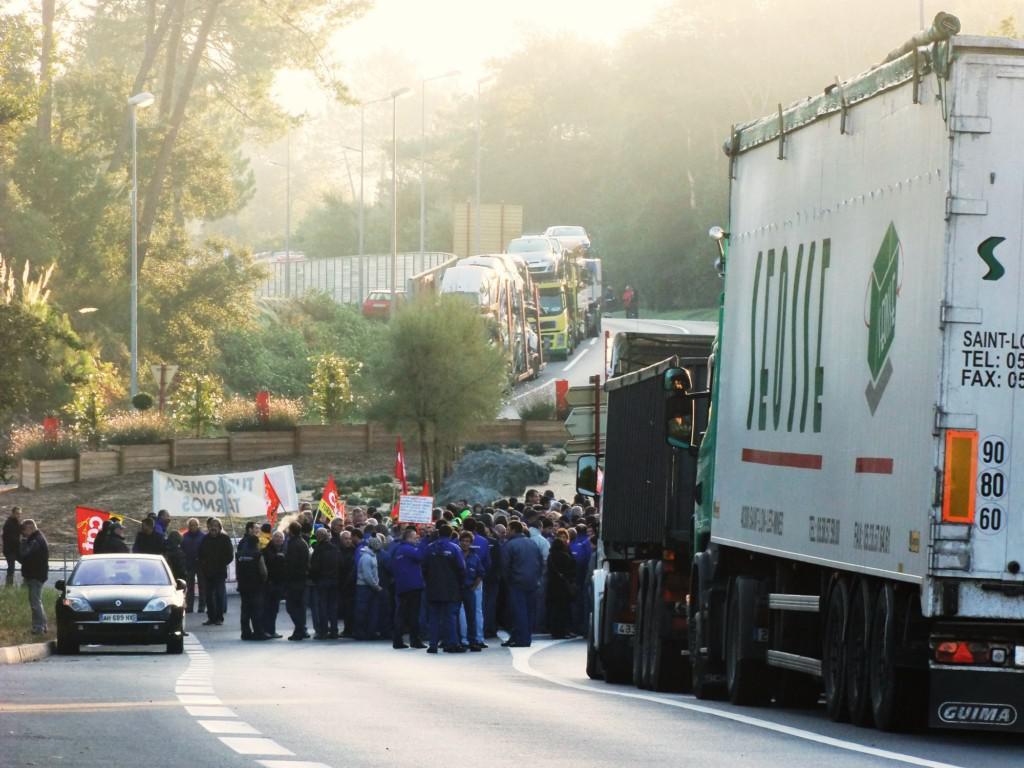Describe this image in one or two sentences. In this image there are a few people standing and holding a banner and a few flags in their hands, there are a few vehicles on the road. In the background there are trees, street lights, railing and the sky. 